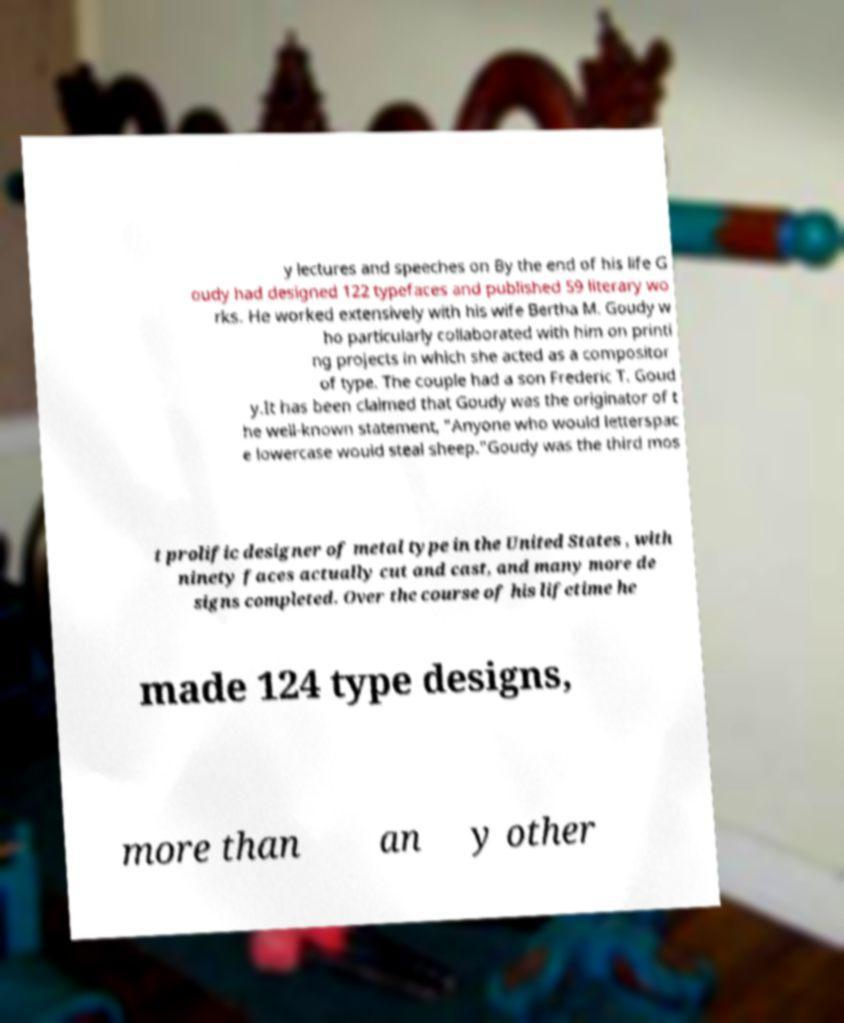Please identify and transcribe the text found in this image. y lectures and speeches on By the end of his life G oudy had designed 122 typefaces and published 59 literary wo rks. He worked extensively with his wife Bertha M. Goudy w ho particularly collaborated with him on printi ng projects in which she acted as a compositor of type. The couple had a son Frederic T. Goud y.It has been claimed that Goudy was the originator of t he well-known statement, "Anyone who would letterspac e lowercase would steal sheep."Goudy was the third mos t prolific designer of metal type in the United States , with ninety faces actually cut and cast, and many more de signs completed. Over the course of his lifetime he made 124 type designs, more than an y other 